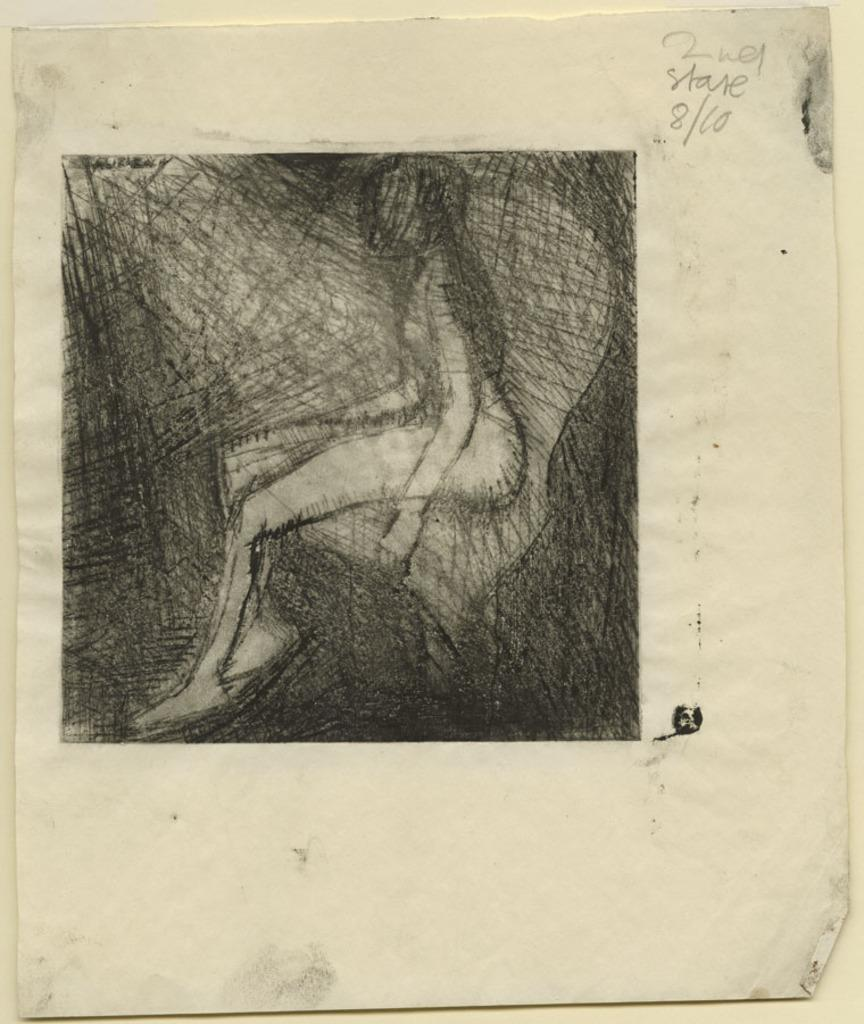What is depicted in the image? The image contains a sketch of a woman. What is the medium used for the sketch? The sketch is drawn on white paper. What color is the paper on which the sketch is drawn? The paper is white. What can be inferred about the background of the image? The background of the image is white. Can you describe the possible setting for the sketch? The white paper might be pasted on a white wall. What type of smell can be detected from the sketch in the image? There is no smell associated with the sketch in the image, as it is a two-dimensional representation on paper. 